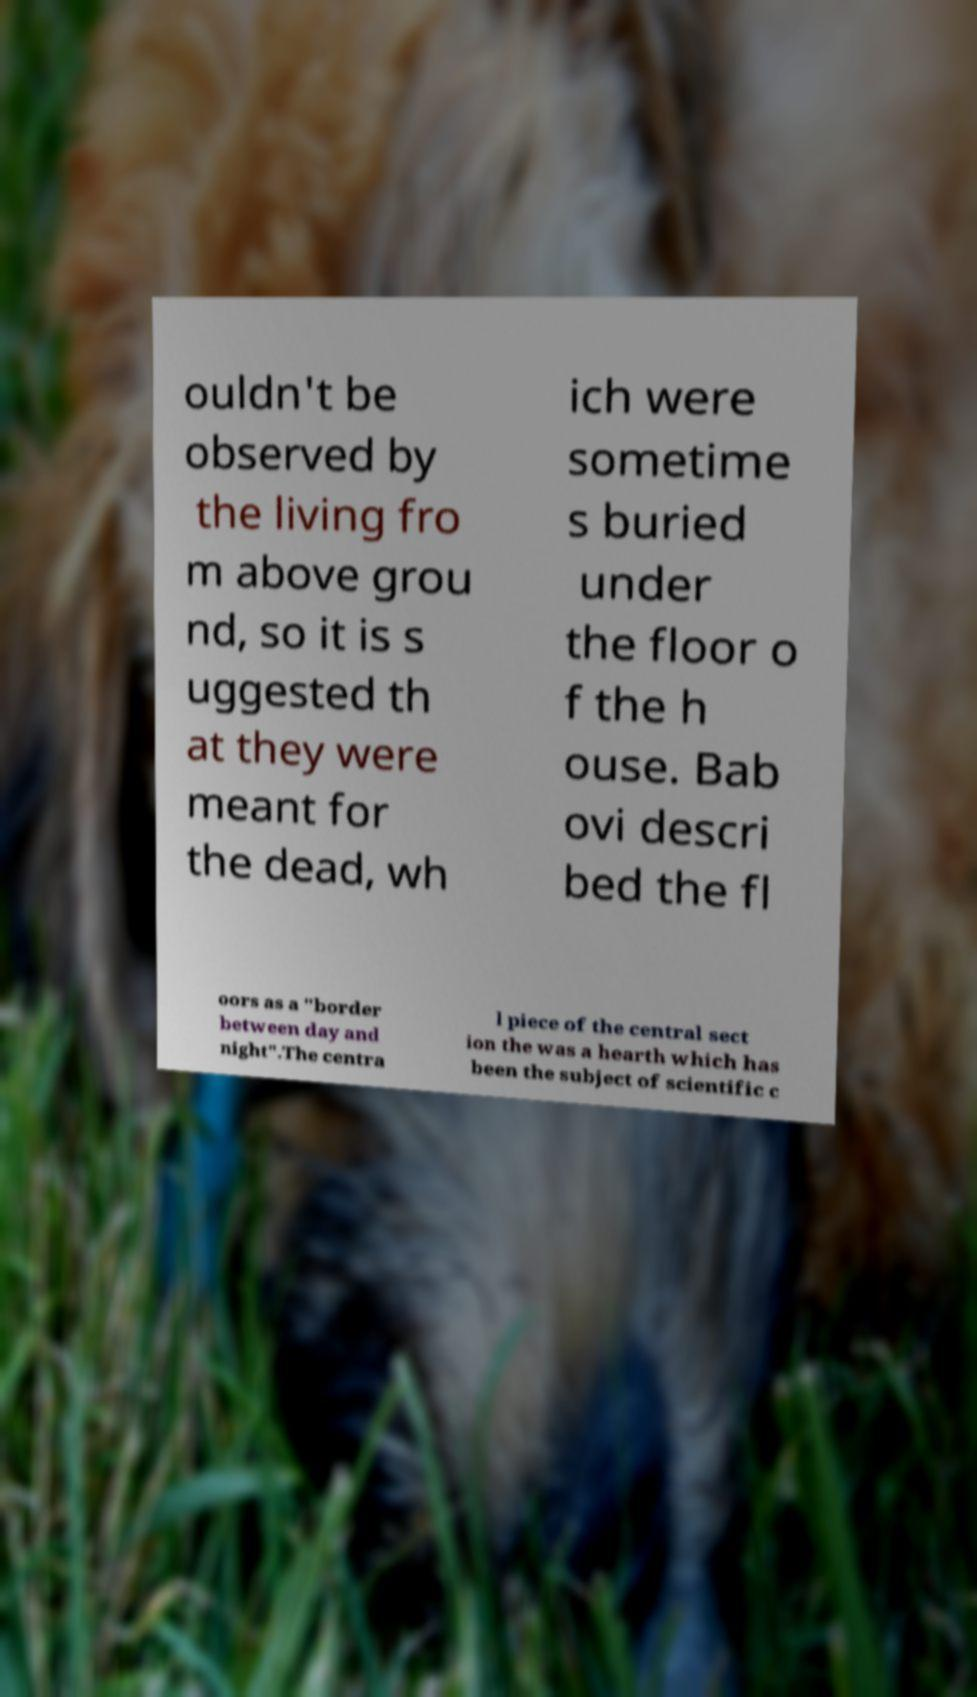Please identify and transcribe the text found in this image. ouldn't be observed by the living fro m above grou nd, so it is s uggested th at they were meant for the dead, wh ich were sometime s buried under the floor o f the h ouse. Bab ovi descri bed the fl oors as a "border between day and night".The centra l piece of the central sect ion the was a hearth which has been the subject of scientific c 